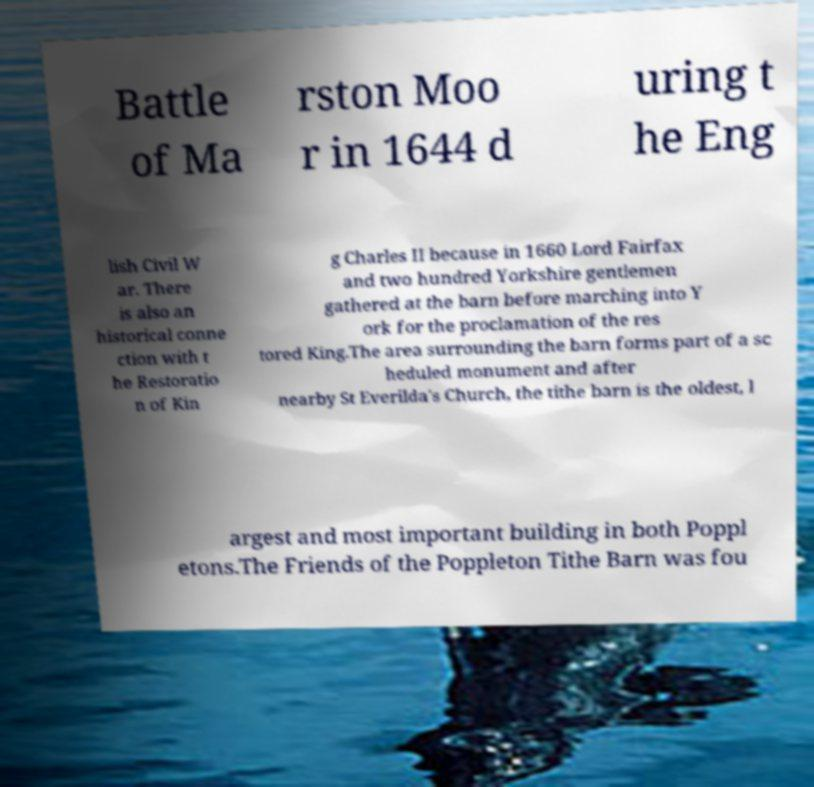I need the written content from this picture converted into text. Can you do that? Battle of Ma rston Moo r in 1644 d uring t he Eng lish Civil W ar. There is also an historical conne ction with t he Restoratio n of Kin g Charles II because in 1660 Lord Fairfax and two hundred Yorkshire gentlemen gathered at the barn before marching into Y ork for the proclamation of the res tored King.The area surrounding the barn forms part of a sc heduled monument and after nearby St Everilda's Church, the tithe barn is the oldest, l argest and most important building in both Poppl etons.The Friends of the Poppleton Tithe Barn was fou 